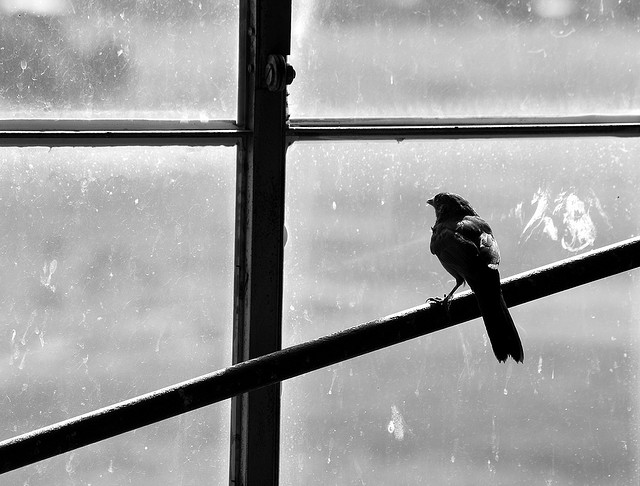<image>What color is this picture? It's ambiguous what color the picture is. It can be black and white or grey. What color is this picture? I don't know what color is in this picture. It seems to be black and white but it can also be gray. 